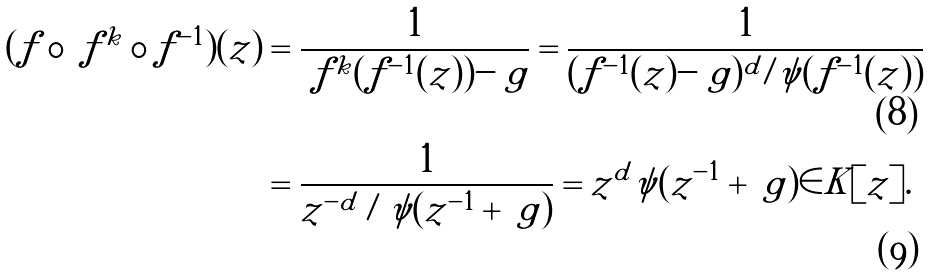<formula> <loc_0><loc_0><loc_500><loc_500>( f \circ \ f ^ { k } \circ f ^ { - 1 } ) ( z ) & = \frac { 1 } { \ f ^ { k } ( f ^ { - 1 } ( z ) ) - \ g } = \frac { 1 } { ( f ^ { - 1 } ( z ) - \ g ) ^ { d } / \psi ( f ^ { - 1 } ( z ) ) } \\ & = \frac { 1 } { z ^ { - d } / \psi ( z ^ { - 1 } + \ g ) } = z ^ { d } \psi ( z ^ { - 1 } + \ g ) \in K [ z ] .</formula> 